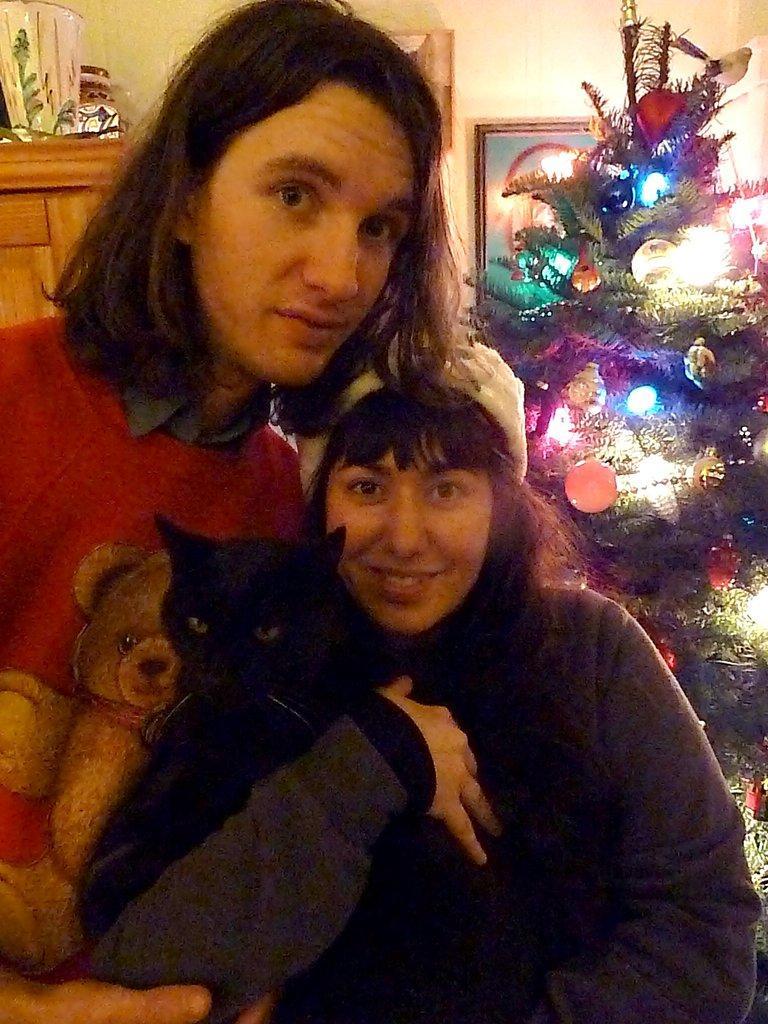Could you give a brief overview of what you see in this image? In this image there is a man , woman and a cat and the back ground there is a christmas tree , frame attached to a wall , and a wooden cupboard. 